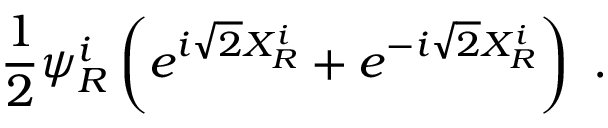<formula> <loc_0><loc_0><loc_500><loc_500>\frac { 1 } { 2 } \psi _ { R } ^ { i } \left ( e ^ { i \sqrt { 2 } X _ { R } ^ { i } } + e ^ { - i \sqrt { 2 } X _ { R } ^ { i } } \right ) \ .</formula> 